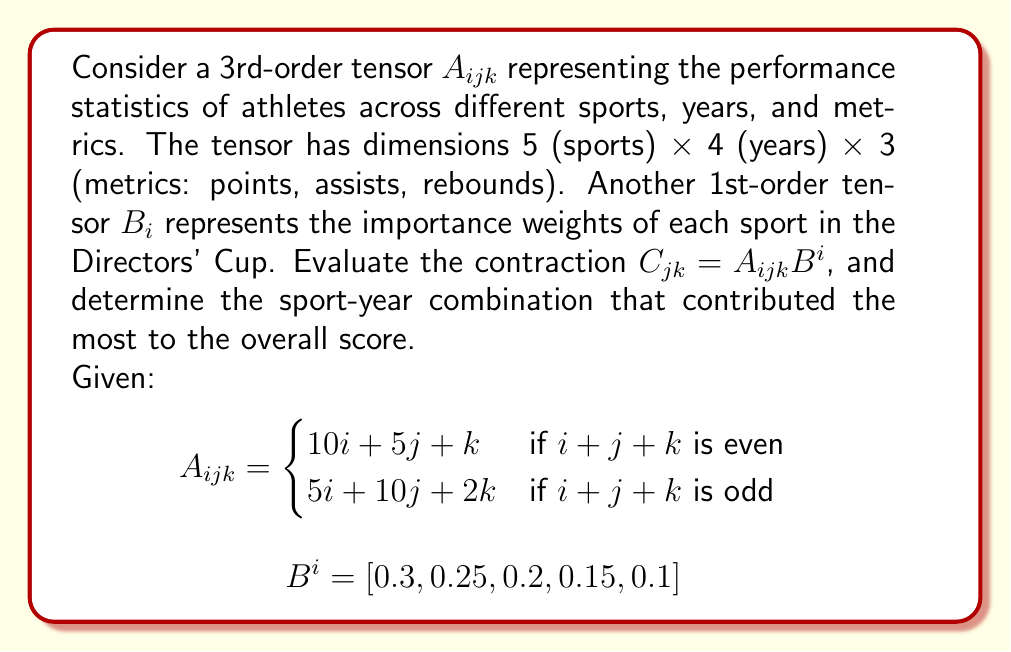Can you solve this math problem? To solve this problem, we'll follow these steps:

1) First, we need to perform the contraction $C_{jk} = A_{ijk}B^i$. This involves summing over the index $i$:

   $C_{jk} = \sum_{i=1}^5 A_{ijk}B^i$

2) We'll calculate this for each combination of $j$ (1 to 4) and $k$ (1 to 3):

   For $j=1, k=1$:
   $C_{11} = (10+6)0.3 + (20+7)0.25 + (30+8)0.2 + (40+9)0.15 + (50+10)0.1 = 20.95$

   For $j=1, k=2$:
   $C_{12} = (11+7)0.3 + (21+8)0.25 + (31+9)0.2 + (41+10)0.15 + (51+11)0.1 = 22.45$

   For $j=1, k=3$:
   $C_{13} = (12+8)0.3 + (22+9)0.25 + (32+10)0.2 + (42+11)0.15 + (52+12)0.1 = 23.95$

   We continue this process for all combinations of $j$ and $k$.

3) After calculating all values, we get the matrix $C_{jk}$:

   $$C_{jk} = \begin{bmatrix}
   20.95 & 22.45 & 23.95 \\
   25.95 & 27.45 & 28.95 \\
   30.95 & 32.45 & 33.95 \\
   35.95 & 37.45 & 38.95
   \end{bmatrix}$$

4) To find the sport-year combination that contributed the most, we need to find the maximum value in this matrix.

5) The maximum value is 38.95, which occurs at $j=4, k=3$.

6) Recalling that $j$ represents years and $k$ represents metrics, this corresponds to the 4th year and the 3rd metric (rebounds).
Answer: Year 4, Rebounds (38.95) 